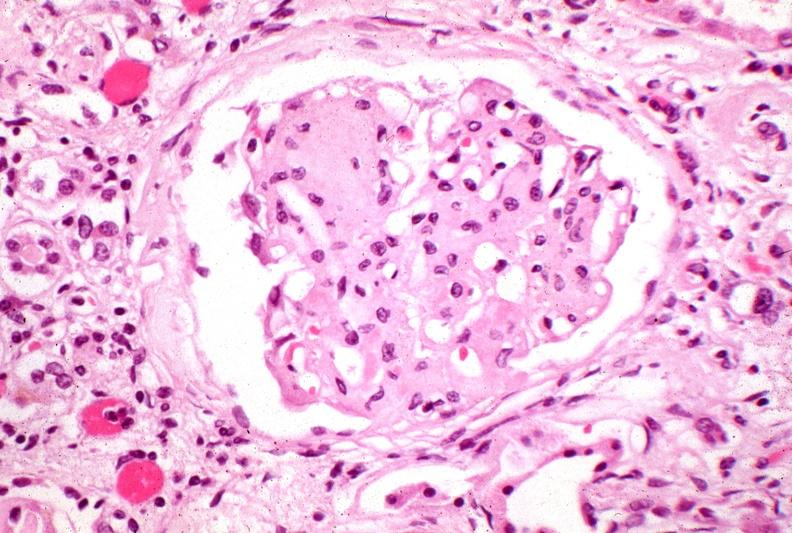what does this image show?
Answer the question using a single word or phrase. Kidney 